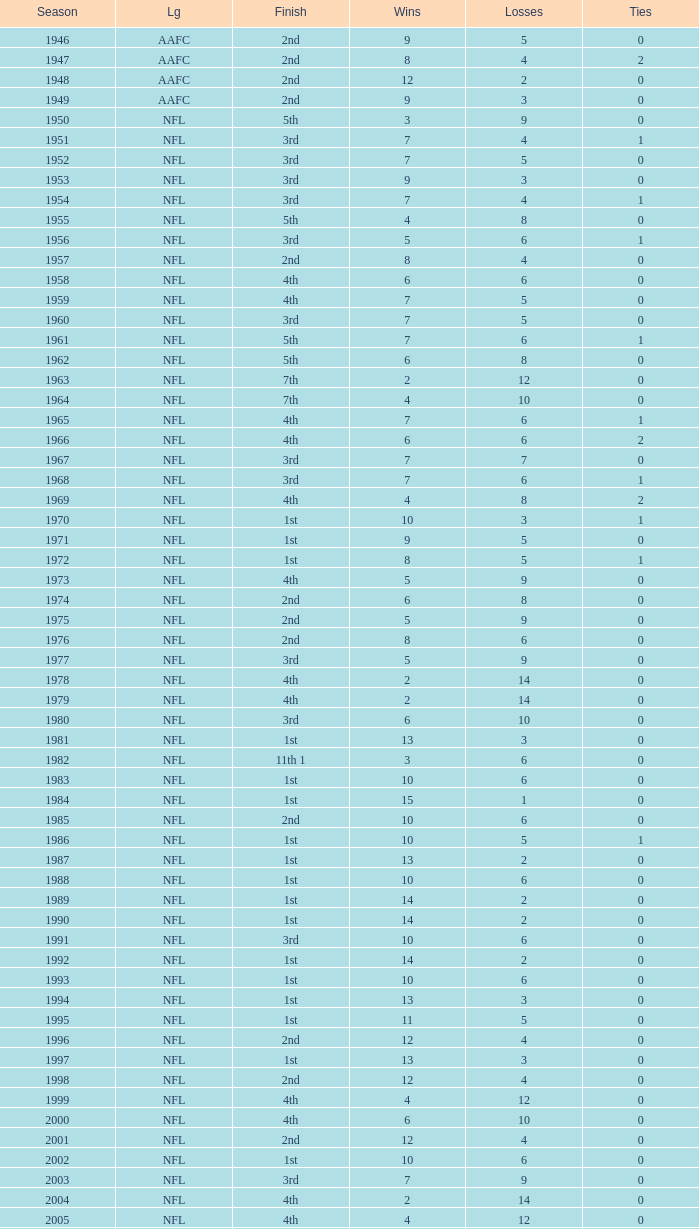What is the number of losses when the ties are lesser than 0? 0.0. 